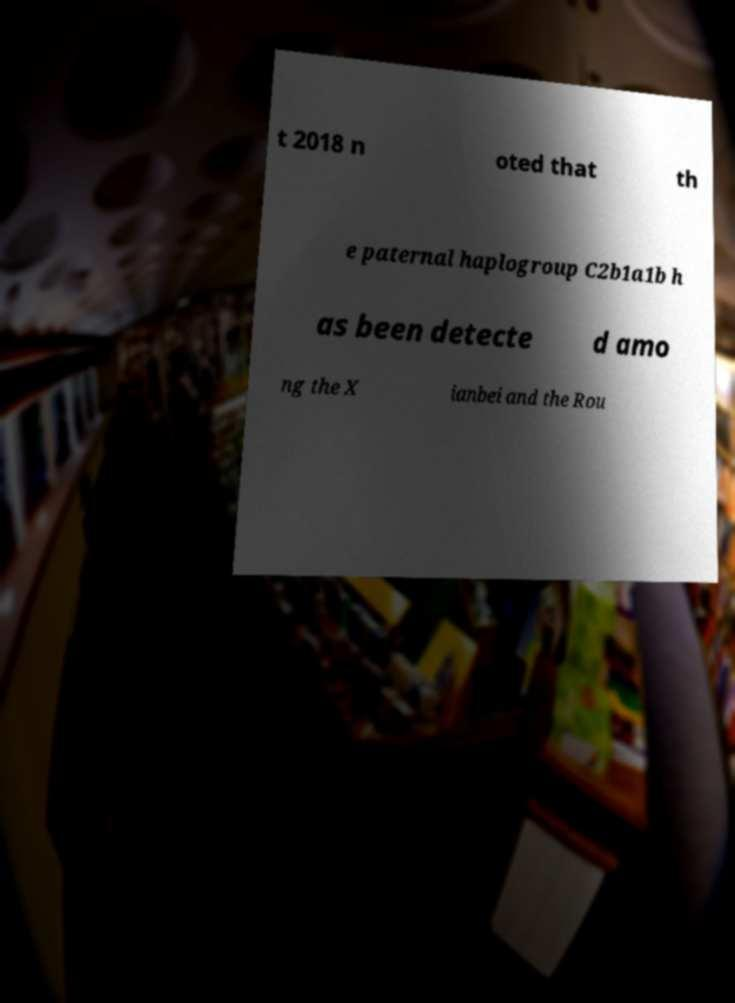Could you assist in decoding the text presented in this image and type it out clearly? t 2018 n oted that th e paternal haplogroup C2b1a1b h as been detecte d amo ng the X ianbei and the Rou 